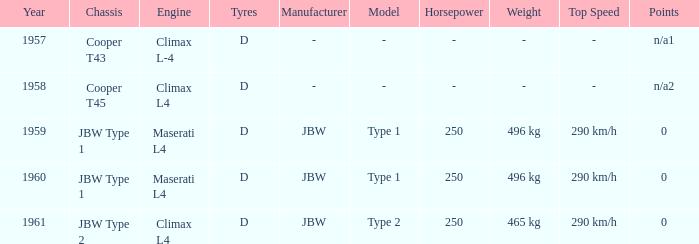What is the engine for a vehicle in 1960? Maserati L4. 